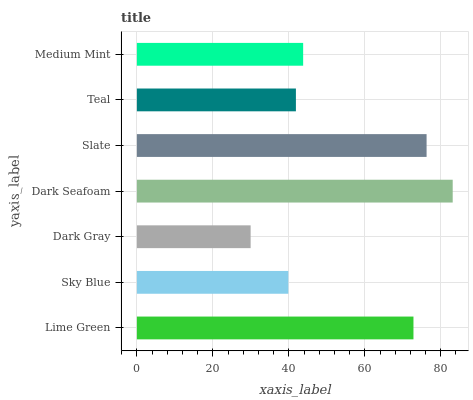Is Dark Gray the minimum?
Answer yes or no. Yes. Is Dark Seafoam the maximum?
Answer yes or no. Yes. Is Sky Blue the minimum?
Answer yes or no. No. Is Sky Blue the maximum?
Answer yes or no. No. Is Lime Green greater than Sky Blue?
Answer yes or no. Yes. Is Sky Blue less than Lime Green?
Answer yes or no. Yes. Is Sky Blue greater than Lime Green?
Answer yes or no. No. Is Lime Green less than Sky Blue?
Answer yes or no. No. Is Medium Mint the high median?
Answer yes or no. Yes. Is Medium Mint the low median?
Answer yes or no. Yes. Is Lime Green the high median?
Answer yes or no. No. Is Slate the low median?
Answer yes or no. No. 